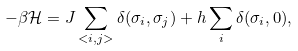Convert formula to latex. <formula><loc_0><loc_0><loc_500><loc_500>\mathcal { - \beta H } = J \sum _ { < i , j > } \delta ( \sigma _ { i } , \sigma _ { j } ) + h \sum _ { i } \delta ( \sigma _ { i } , 0 ) ,</formula> 